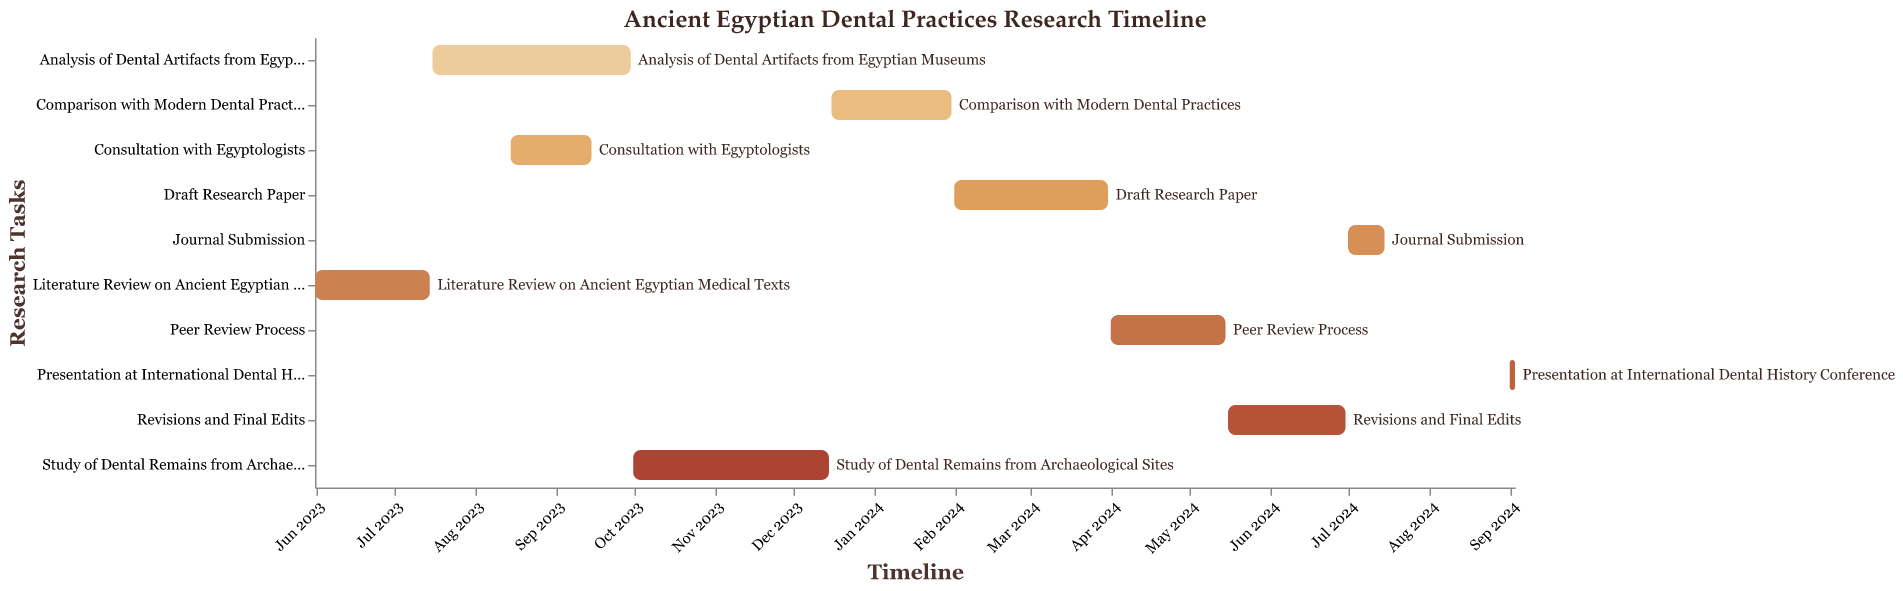How many research tasks are outlined in the figure? Count the number of unique tasks listed on the y-axis of the Gantt Chart.
Answer: 10 Which task has the earliest start date? Look for the start date closest to the leftmost side of the Gantt Chart to find the earliest beginning.
Answer: Literature Review on Ancient Egyptian Medical Texts How long does the Analysis of Dental Artifacts from Egyptian Museums task last? Calculate the duration from the start to the end date for the specified task. Specifically, "Analysis of Dental Artifacts from Egyptian Museums" starts on July 16, 2023, and ends on September 30, 2023, which spans (30–16+1 in July + 30 days in August + 30 days in September).
Answer: 76 days Which task overlaps with the Analysis of Dental Artifacts from Egyptian Museums? Identify tasks whose durations overlap with the one named. The "Consultation with Egyptologists" runs from August 15, 2023, to September 15, 2023, overlapping both in August and September.
Answer: Consultation with Egyptologists From the end of the Peer Review Process, how much time is there before the start of the Revisions and Final Edits? Calculate the gap between the end date of "Peer Review Process" (May 15, 2024) and the start date of "Revisions and Final Edits" (May 16, 2024).
Answer: 1 day How does the duration of the Study of Dental Remains from Archaeological Sites compare with the Draft Research Paper process? Calculate the duration of the two tasks and compare them. "Study of Dental Remains from Archaeological Sites" lasts from October 1, 2023, to December 15, 2023, which is 76 days. "Draft Research Paper" is from February 1, 2024, to March 31, 2024, totaling 60 days. "Study of Dental Remains from Archaeological Sites" is longer.
Answer: Study of Dental Remains from Archaeological Sites is longer by 16 days List the tasks that last longer than 2 months. Identify tasks whose duration spans more than 2 months by calculating their respective durations. "Analysis of Dental Artifacts from Egyptian Museums" (76 days), "Study of Dental Remains from Archaeological Sites" (76 days), "Comparison with Modern Dental Practices" (46 days), "Draft Research Paper" (60 days), and "Revisions and Final Edits" (46 days).
Answer: Analysis of Dental Artifacts from Egyptian Museums, Study of Dental Remains from Archaeological Sites, Draft Research Paper Which phase begins immediately after the Study of Dental Remains from Archaeological Sites ends? Check which task starts on December 16, 2023, the day after the "Study of Dental Remains from Archaeological Sites" ends (December 15, 2023).
Answer: Comparison with Modern Dental Practices How long is the time gap between the final edits completion and the journal submission? Determine the number of days between the end date of "Revisions and Final Edits" (June 30, 2024) and the start of "Journal Submission" (July 1, 2024).
Answer: 1 day 